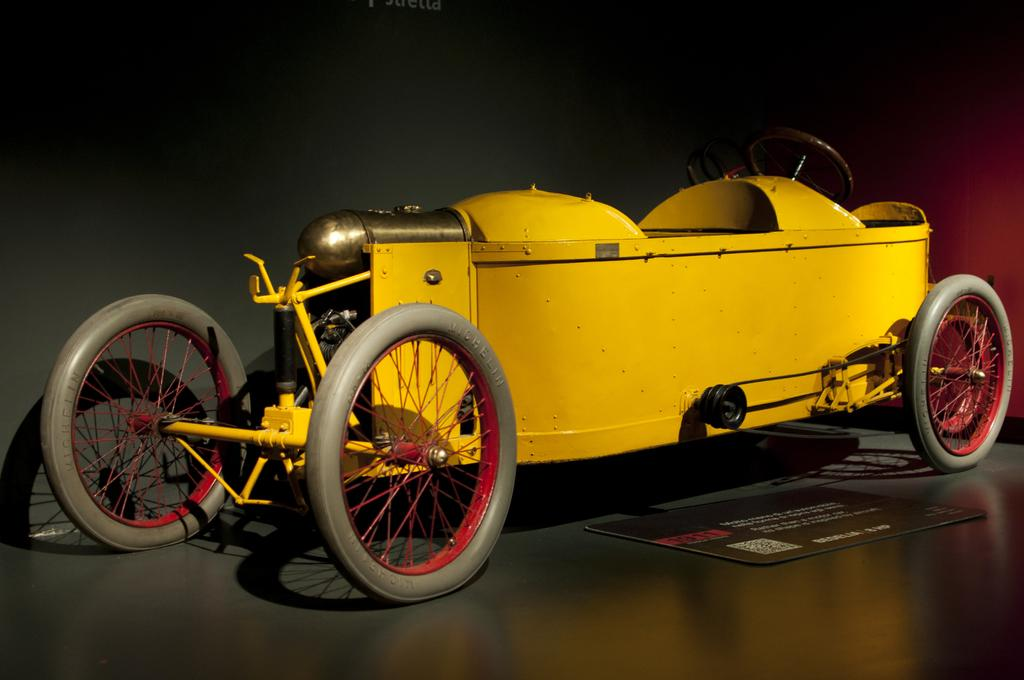What color is the vehicle in the image? The vehicle in the image is yellow. What type of object is placed beside the vehicle on the ground? Unfortunately, the provided facts do not specify the type of object placed beside the vehicle. Is the grandmother swimming in the image? There is no mention of a grandmother or swimming in the provided facts, so we cannot answer that question. 